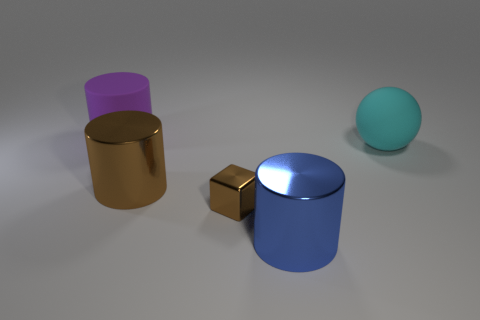How many things are both behind the tiny brown metal block and left of the cyan sphere?
Your answer should be very brief. 2. How many other objects are the same size as the cyan object?
Provide a short and direct response. 3. Is the shape of the rubber thing that is to the left of the brown shiny block the same as the large metallic object to the left of the big blue metallic cylinder?
Ensure brevity in your answer.  Yes. There is a matte sphere; are there any metal blocks left of it?
Give a very brief answer. Yes. What is the color of the rubber thing that is the same shape as the blue metallic object?
Your answer should be very brief. Purple. Is there any other thing that has the same shape as the small brown thing?
Offer a very short reply. No. There is a large cylinder that is behind the large cyan rubber object; what is its material?
Give a very brief answer. Rubber. How many purple cylinders have the same material as the small brown object?
Give a very brief answer. 0. What number of large rubber objects are the same color as the matte cylinder?
Make the answer very short. 0. How many objects are either cylinders that are behind the cyan object or cylinders on the right side of the purple cylinder?
Your answer should be compact. 3. 